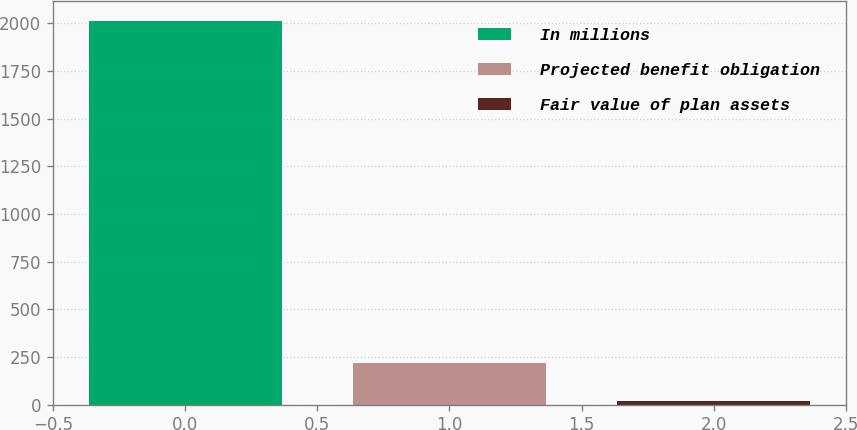Convert chart to OTSL. <chart><loc_0><loc_0><loc_500><loc_500><bar_chart><fcel>In millions<fcel>Projected benefit obligation<fcel>Fair value of plan assets<nl><fcel>2015<fcel>216.44<fcel>16.6<nl></chart> 